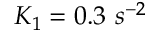Convert formula to latex. <formula><loc_0><loc_0><loc_500><loc_500>K _ { 1 } = 0 . 3 \ s ^ { - 2 }</formula> 